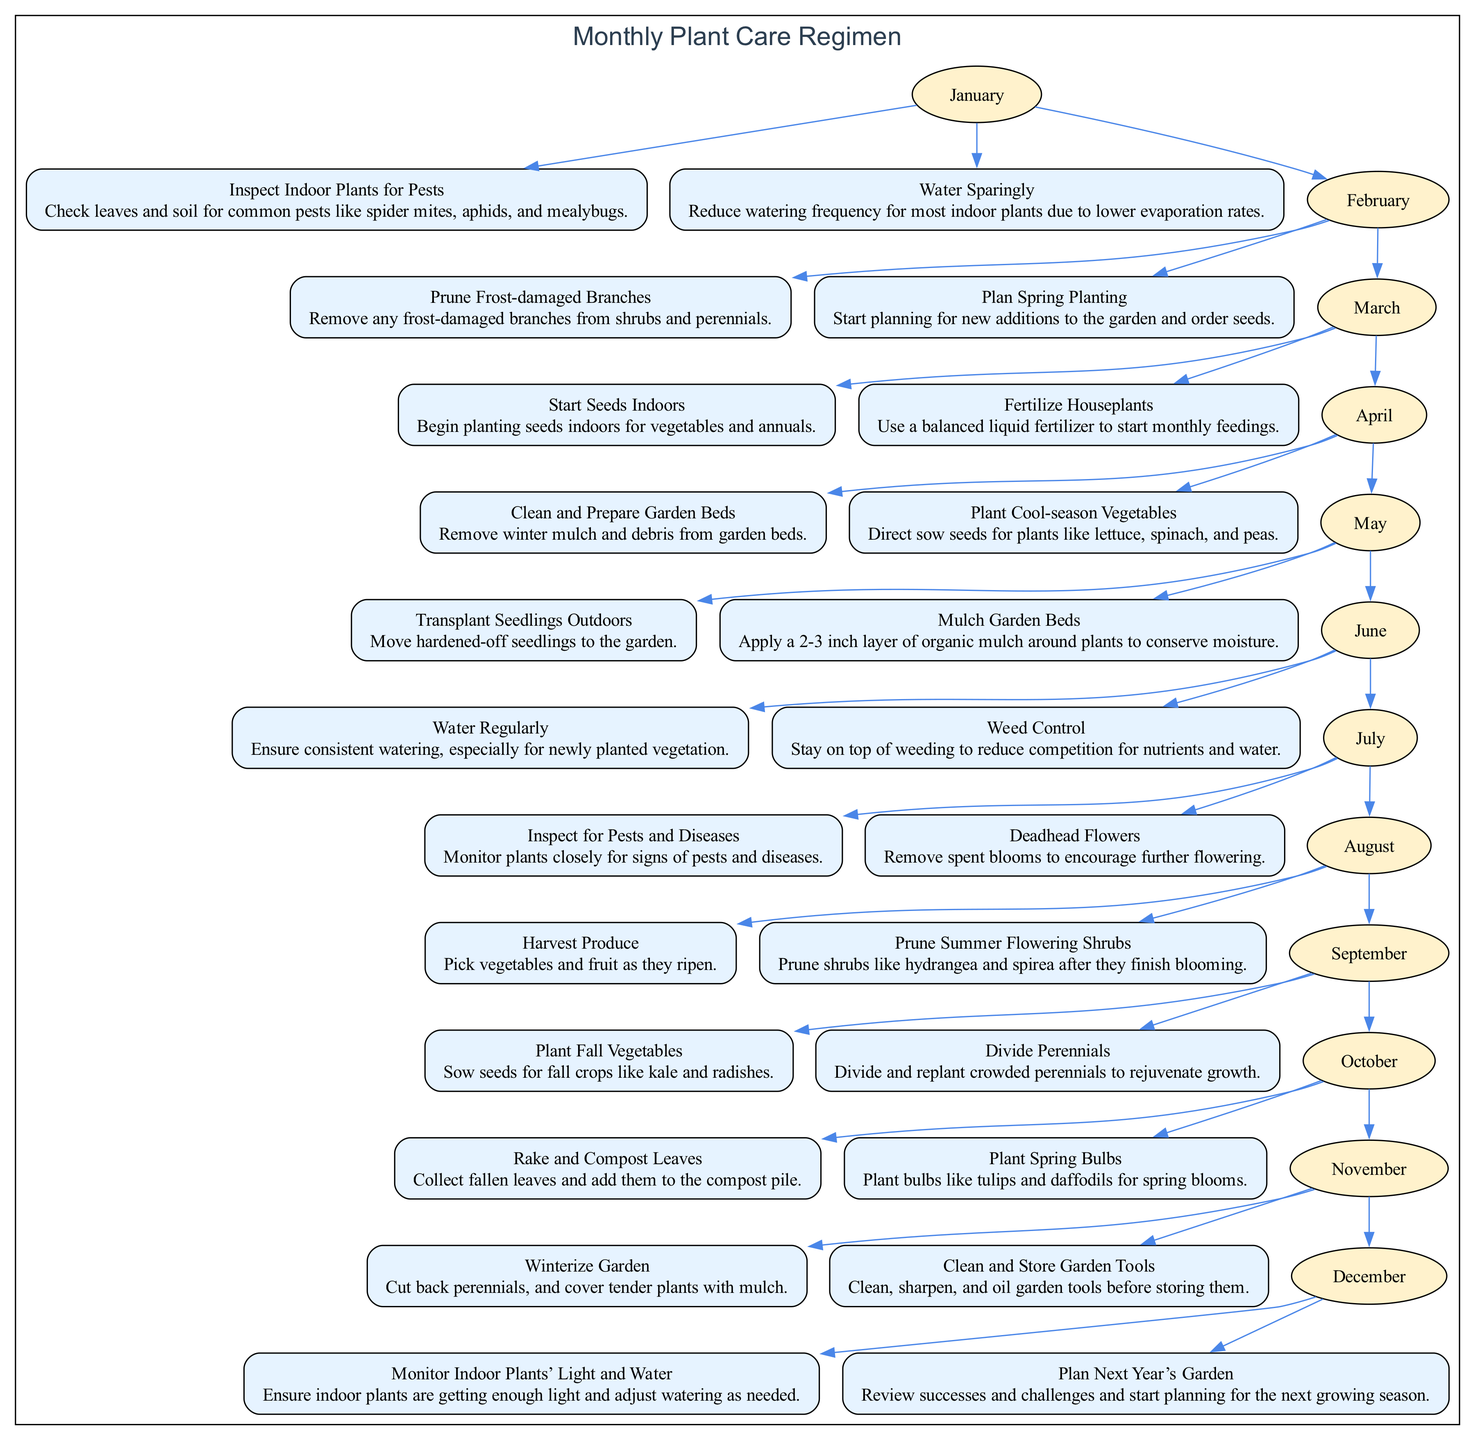What are the tasks for June? In June, the diagram specifies two tasks: "Water Regularly" and "Weed Control". This is derived from the node corresponding to June which directly branches out to the tasks listed beneath it.
Answer: Water Regularly, Weed Control How many months have tasks for planting vegetables? The months that include planting tasks are April, May, August, and September. Counting these months gives a total of four months that specifically mention vegetable planting tasks.
Answer: 4 What is the first task for March? The diagram shows that March has two tasks, the first of which is "Start Seeds Indoors". This is determined by looking at the tasks listed under the March node.
Answer: Start Seeds Indoors Which month involves cleaning and storing garden tools? In the diagram, November is the designated month for "Clean and Store Garden Tools". This is directly linked to the tasks listed for November.
Answer: November What is the relationship between October and December tasks? October involves "Rake and Compost Leaves" and "Plant Spring Bulbs", while December involves "Monitor Indoor Plants’ Light and Water" and "Plan Next Year’s Garden". They are connected in the sequence of months, preceding and succeeding each other, representing month transitions in the maintenance tasks list, indicating that tasks flow chronologically from one month to the next.
Answer: Sequential transition What task is related to harvesting in August? Under August, one of the tasks is "Harvest Produce", directly specified in the tasks for that month.
Answer: Harvest Produce How many tasks are listed for the month of February? The diagram shows two tasks listed for February: "Prune Frost-damaged Branches" and "Plan Spring Planting". Therefore, the total number of tasks for February is two.
Answer: 2 Which task for November involves garden care? The care task listed for November is "Winterize Garden", as noted in the tasks specified under that month.
Answer: Winterize Garden What happens after planting spring bulbs in October? After the October tasks, the next month is November. So, after "Plant Spring Bulbs" in October, the pathway leads to the tasks listed for November.
Answer: Transition to November tasks 